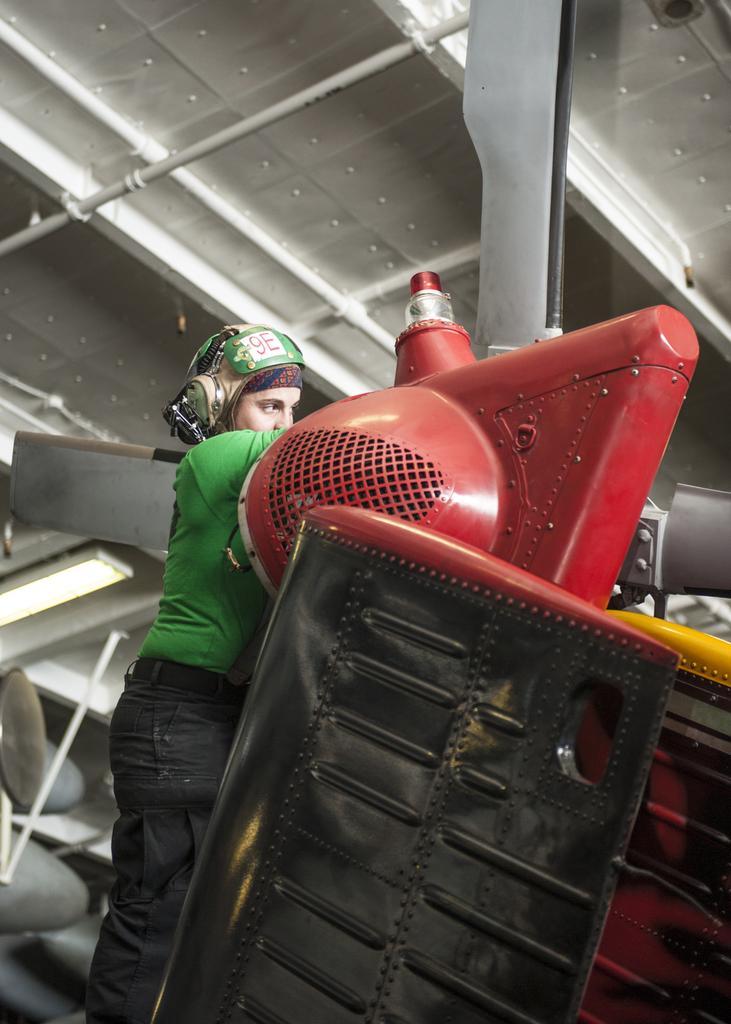Describe this image in one or two sentences. In this picture we can see a person, and the person wore a helmet, in front of the person we can find machinery and few metal rods. 